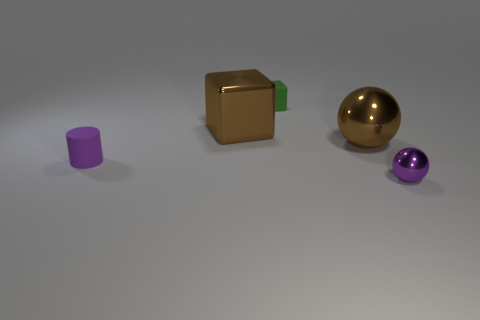Subtract 2 spheres. How many spheres are left? 0 Subtract 0 cyan cubes. How many objects are left? 5 Subtract all cylinders. How many objects are left? 4 Subtract all red cylinders. Subtract all green cubes. How many cylinders are left? 1 Subtract all yellow cylinders. How many purple spheres are left? 1 Subtract all brown shiny things. Subtract all big shiny spheres. How many objects are left? 2 Add 3 green cubes. How many green cubes are left? 4 Add 3 tiny rubber things. How many tiny rubber things exist? 5 Add 3 metal spheres. How many objects exist? 8 